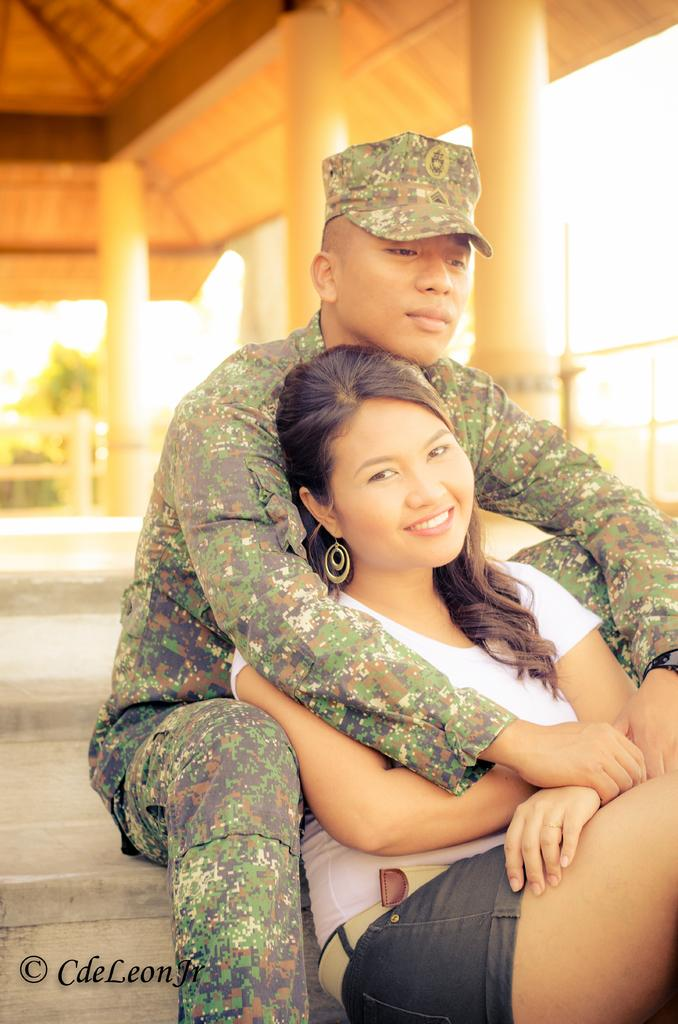Who are the people in the image? There is a man and a lady in the image. What are the man and the lady doing in the image? Both the man and the lady are sitting on the floor. What can be seen above the people in the image? There is a roof visible in the image. How would you describe the background of the image? The background of the image is blurry. What type of nail is the man using to fix the roof in the image? There is no nail or roof-fixing activity depicted in the image; the man and the lady are sitting on the floor. What role does the minister play in the image? There is no minister present in the image. 